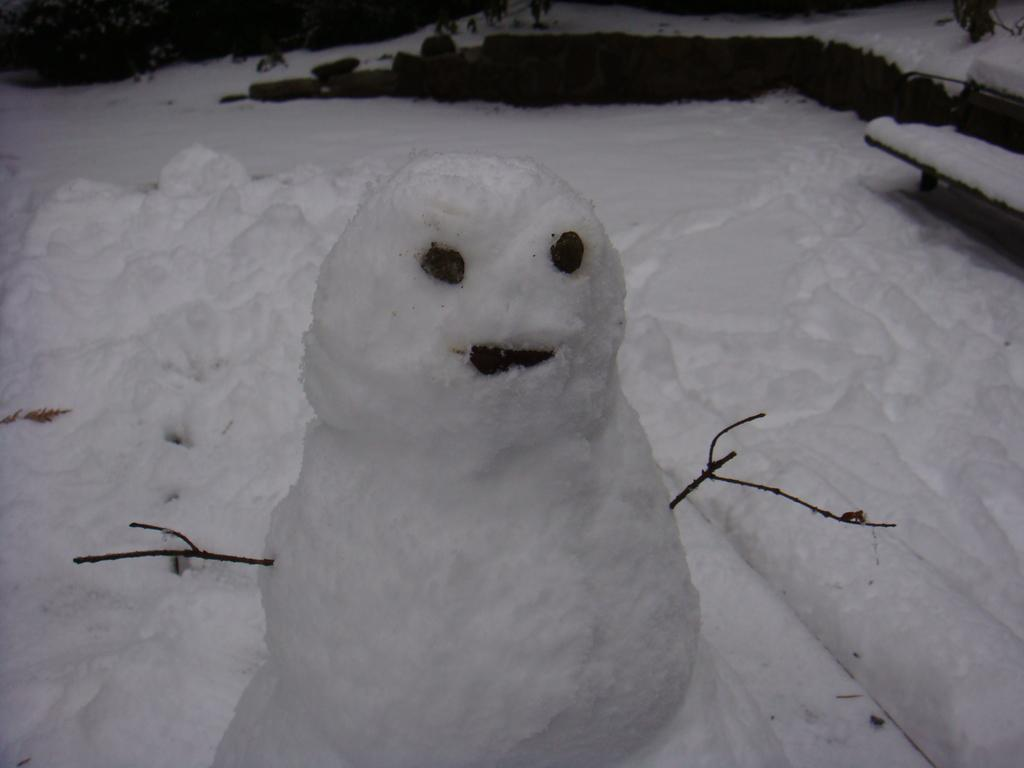What is the main subject of the image? There is a snowman in the image. What can be seen beneath the snowman? The ground is visible in the image. Are there any structures or objects in the image? Yes, there is a bench in the image. How is the bench affected by the snow? The bench is covered with snow. What type of music is the grandfather playing on the bench in the image? There is no grandfather or music present in the image; it features a snowman and a bench covered with snow. 